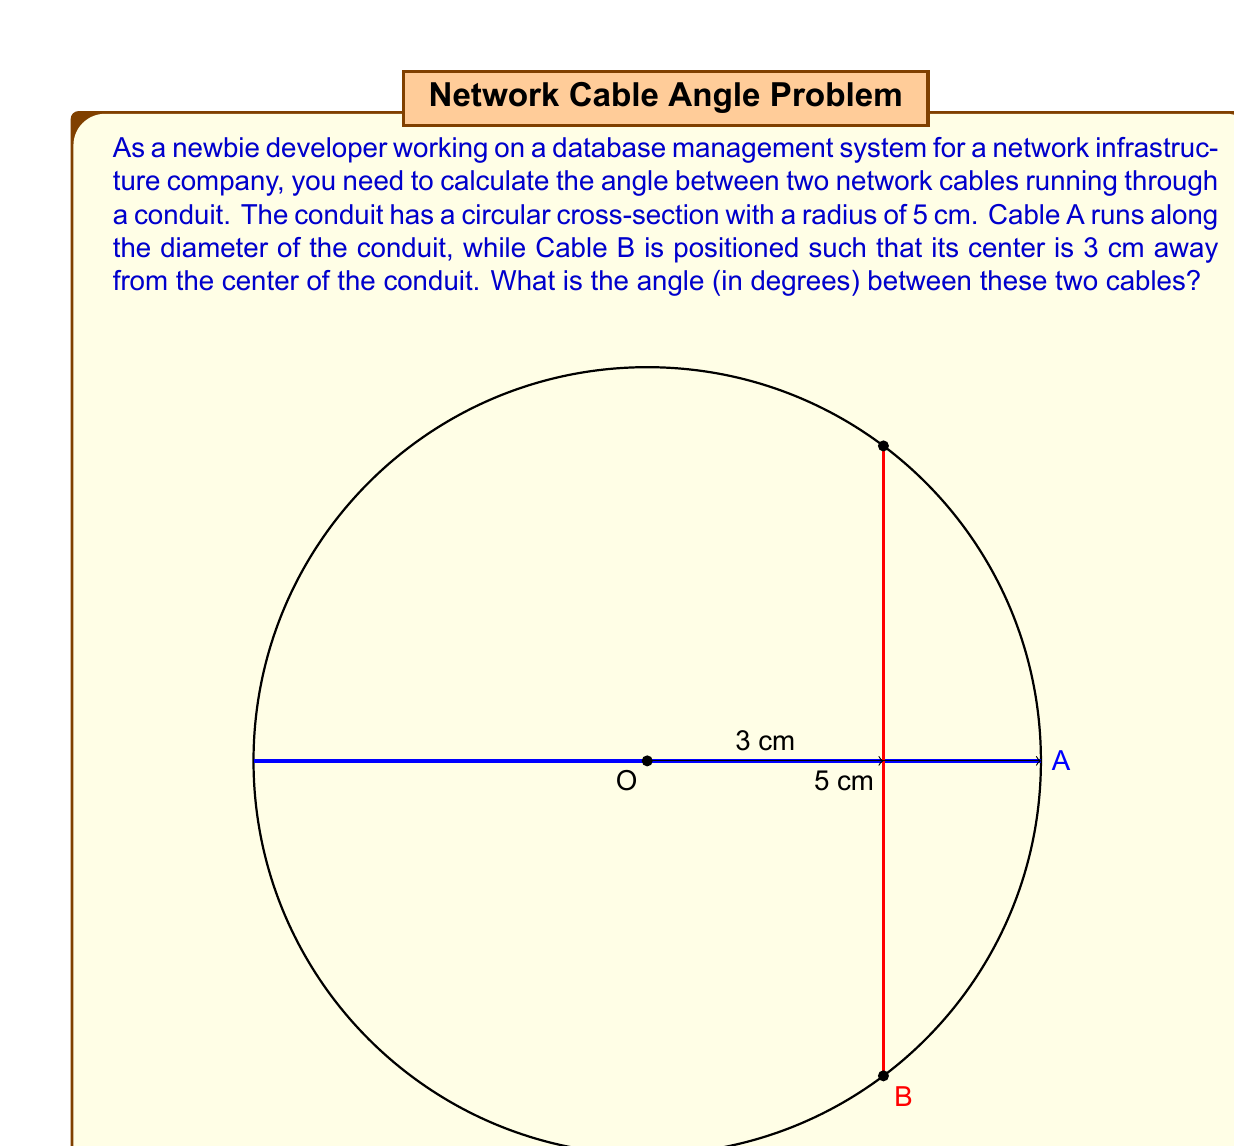Show me your answer to this math problem. To solve this problem, let's follow these steps:

1) First, we need to understand the geometry of the situation. Cable A runs along the diameter, passing through the center of the conduit. Cable B's center is 3 cm away from the center of the conduit.

2) We can treat this as a right-angled triangle problem. The angle we're looking for is between the radius to Cable B's center and the radius along Cable A (which is half of the diameter).

3) In this right-angled triangle:
   - The hypotenuse is the radius of the conduit: 5 cm
   - The adjacent side to our angle is the distance from the center to Cable B's center: 3 cm

4) We can use the cosine function to find this angle. In a right-angled triangle:

   $$ \cos(\theta) = \frac{\text{adjacent}}{\text{hypotenuse}} $$

5) Plugging in our values:

   $$ \cos(\theta) = \frac{3}{5} $$

6) To find $\theta$, we need to take the inverse cosine (arccos) of both sides:

   $$ \theta = \arccos(\frac{3}{5}) $$

7) Using a calculator or programming function to evaluate this:

   $$ \theta \approx 53.13010235415598^\circ $$

8) However, this is only half of the angle between the cables. The full angle is twice this value:

   $$ \text{Full Angle} = 2 \theta \approx 106.26020470831195^\circ $$

9) Rounding to two decimal places gives us our final answer.
Answer: The angle between the two network cables is approximately $106.26^\circ$. 